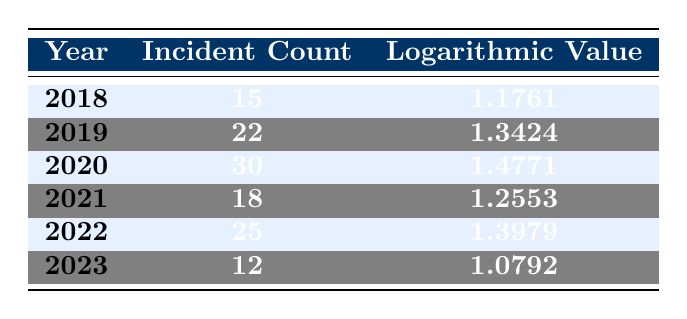What was the incident count for the year 2019? Referring to the table, the row for the year 2019 shows an incident count of 22.
Answer: 22 What is the logarithmic value for the year 2021? The table indicates the logarithmic value for 2021 is 1.2553.
Answer: 1.2553 In which year was the highest number of tampering incidents reported? By examining the incident count for each year, 2020, with 30 incidents, has the highest count compared to other years.
Answer: 2020 What is the total incident count from 2018 to 2023? To find the total, sum the incident counts: 15 (2018) + 22 (2019) + 30 (2020) + 18 (2021) + 25 (2022) + 12 (2023) = 122.
Answer: 122 Is the logarithmic value for 2022 greater than that of 2021? By comparing the values in the table, the logarithmic value for 2022 (1.3979) is indeed greater than for 2021 (1.2553).
Answer: Yes What was the difference in the number of incidents between 2020 and 2022? The difference is calculated by subtracting the incident count of 2022 from that of 2020: 30 (2020) - 25 (2022) = 5.
Answer: 5 Was the incident count in 2023 lower than in 2018? Checking the table, the incident count in 2023 is 12 and in 2018 it is 15. Since 12 is lower than 15, the answer is yes.
Answer: Yes What is the average incident count from 2018 to 2023? To calculate the average, first sum the incident counts (122 as previously calculated) and divide by the number of years (6): 122 / 6 = 20.33.
Answer: 20.33 How many years had an incident count greater than 20? By reviewing the table, 2019 (22), 2020 (30), and 2022 (25) all show counts greater than 20, totaling 3 years.
Answer: 3 